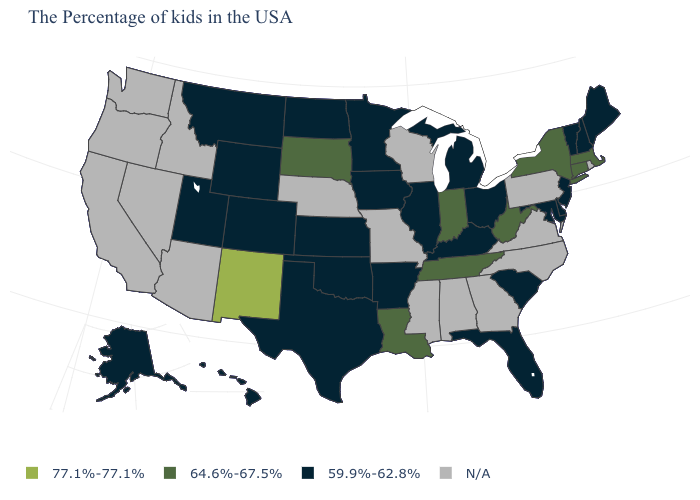What is the highest value in the USA?
Short answer required. 77.1%-77.1%. Which states have the lowest value in the West?
Answer briefly. Wyoming, Colorado, Utah, Montana, Alaska, Hawaii. What is the value of California?
Write a very short answer. N/A. How many symbols are there in the legend?
Give a very brief answer. 4. Which states have the highest value in the USA?
Short answer required. New Mexico. Which states have the highest value in the USA?
Keep it brief. New Mexico. Does the first symbol in the legend represent the smallest category?
Answer briefly. No. Does New Mexico have the highest value in the West?
Give a very brief answer. Yes. Which states hav the highest value in the West?
Give a very brief answer. New Mexico. Does North Dakota have the lowest value in the USA?
Keep it brief. Yes. Which states have the highest value in the USA?
Concise answer only. New Mexico. How many symbols are there in the legend?
Write a very short answer. 4. Among the states that border Maine , which have the lowest value?
Concise answer only. New Hampshire. 